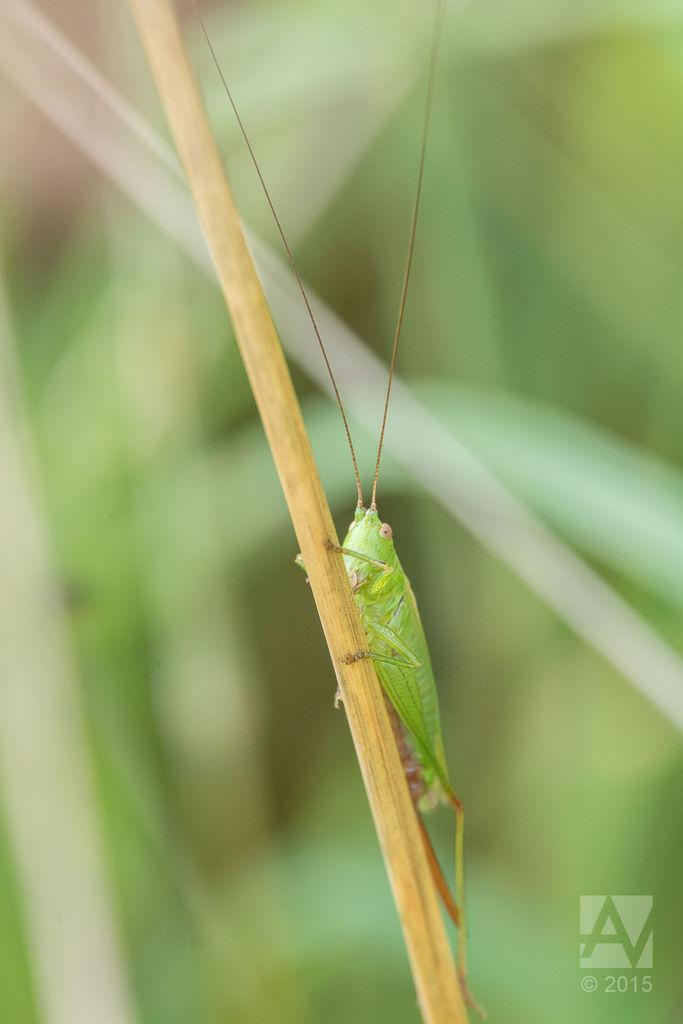What is the main subject of the image? The main subject of the image is a grasshopper. Where is the grasshopper located in the image? The grasshopper is on a branch in the image. Can you describe any additional features of the image? Yes, there is a watermark on the image. What type of steam can be seen rising from the grasshopper's territory in the image? There is no steam or territory present in the image; it features a grasshopper on a branch with a watermark. 